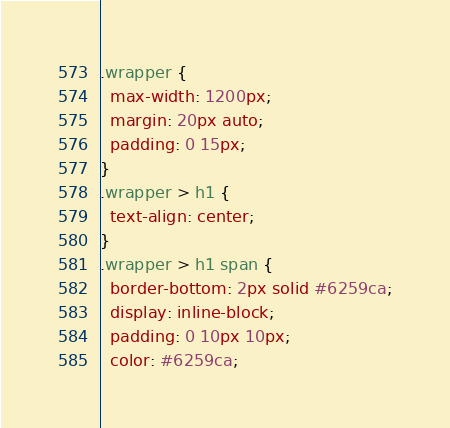Convert code to text. <code><loc_0><loc_0><loc_500><loc_500><_CSS_>
.wrapper {
  max-width: 1200px;
  margin: 20px auto;
  padding: 0 15px;
}
.wrapper > h1 {
  text-align: center;
}
.wrapper > h1 span {
  border-bottom: 2px solid #6259ca;
  display: inline-block;
  padding: 0 10px 10px;
  color: #6259ca;</code> 